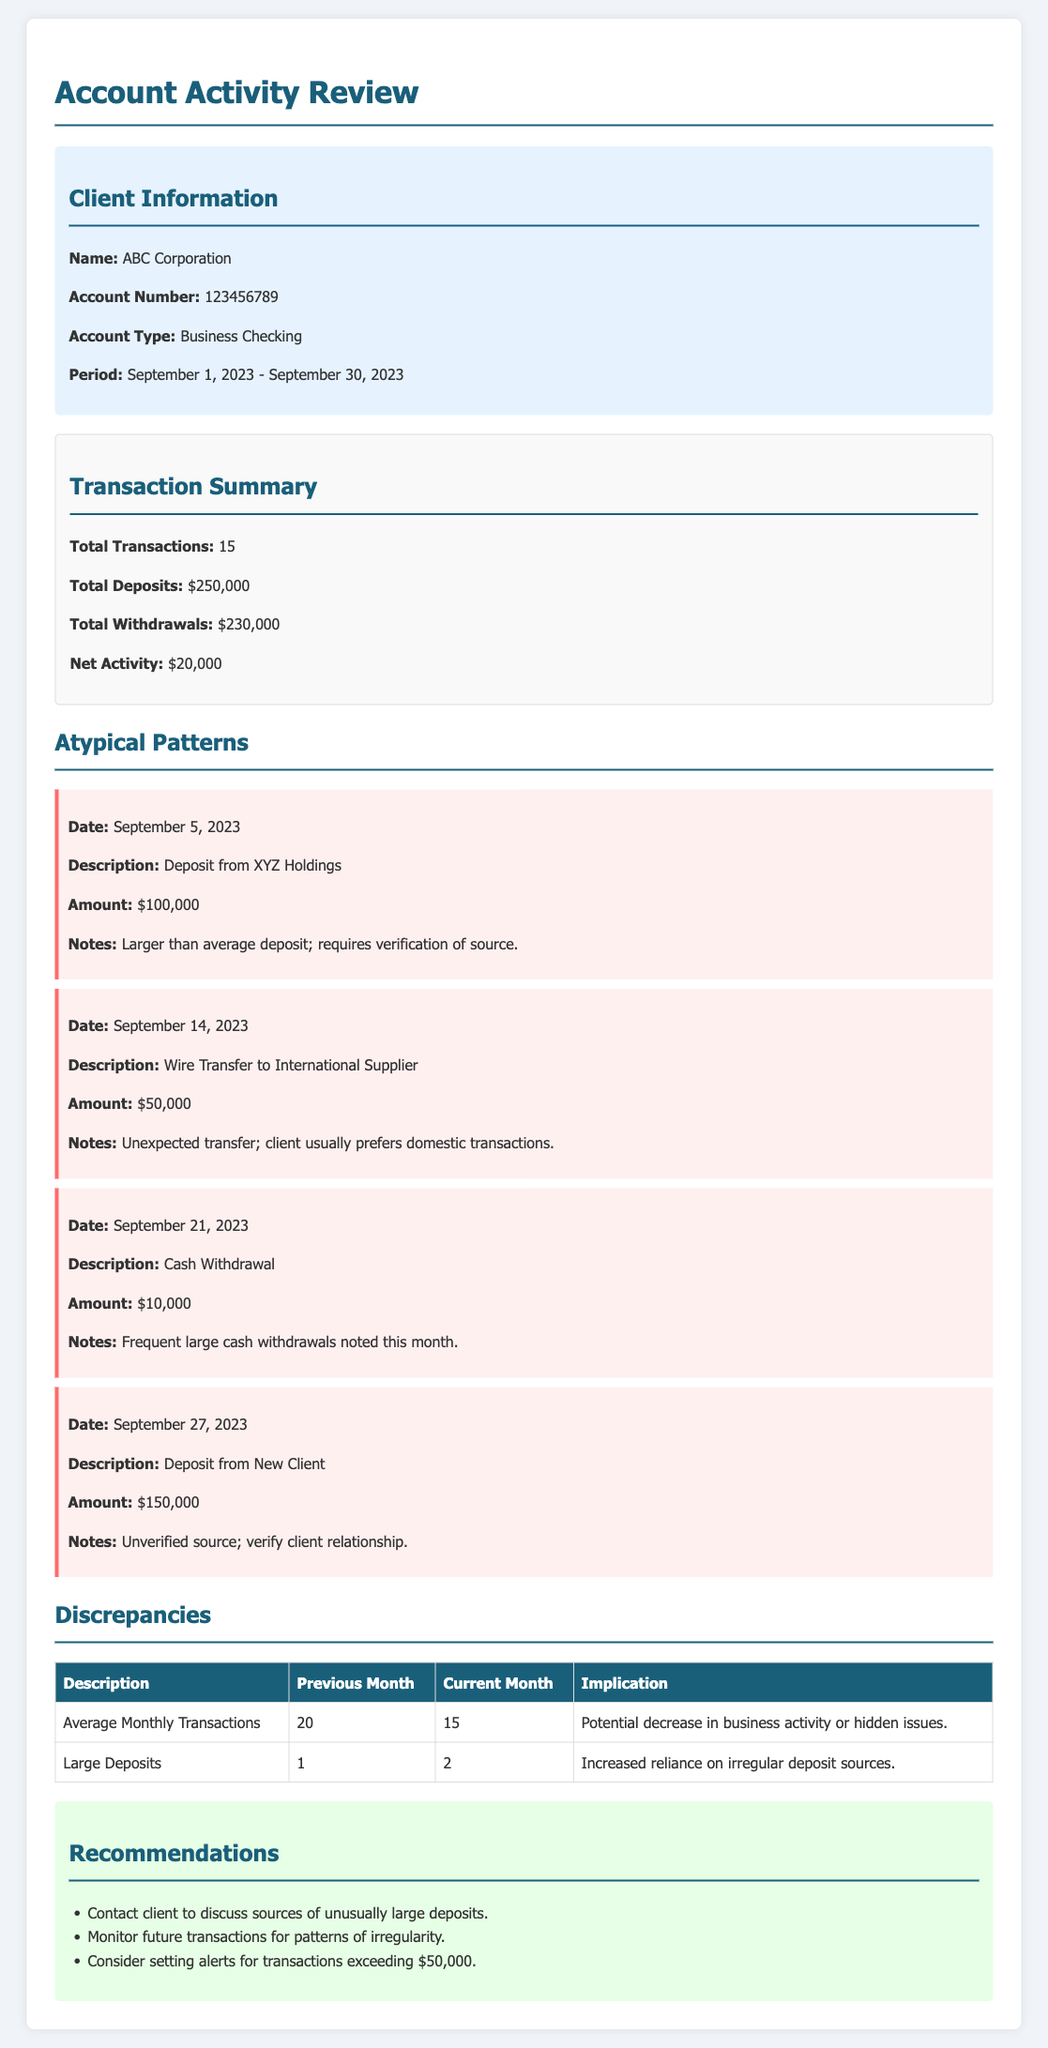What is the total amount of deposits for September 2023? The total amount of deposits includes all deposits made in the specified period, which is $250,000.
Answer: $250,000 What was the amount of the largest single deposit? The document highlights a deposit from XYZ Holdings on September 5, 2023, which was larger than average, amounting to $100,000.
Answer: $100,000 How many total transactions were there in September 2023? The number of total transactions listed in the transaction summary is 15.
Answer: 15 What discrepancy is noted regarding average monthly transactions? The table indicates that the average monthly transactions decreased from 20 to 15.
Answer: 20 to 15 What was the amount of the withdrawal on September 21, 2023? A cash withdrawal of $10,000 was recorded on September 21, 2023.
Answer: $10,000 What implication is associated with the increased large deposits? The implication mentioned is an increased reliance on irregular deposit sources.
Answer: Increased reliance on irregular deposit sources What type of transaction is noted as unexpected on September 14, 2023? A wire transfer to an international supplier is noted as unexpected in the context of the client's usual transaction preferences.
Answer: Wire Transfer to International Supplier What is one recommendation provided in the document? One of the recommendations is to contact the client to discuss sources of unusually large deposits.
Answer: Contact client to discuss sources of unusually large deposits What is the net activity for the account in September 2023? The net activity is calculated as total deposits minus total withdrawals, which amounts to $20,000.
Answer: $20,000 Which date showed a deposit from a new client? A deposit from a new client was noted on September 27, 2023.
Answer: September 27, 2023 